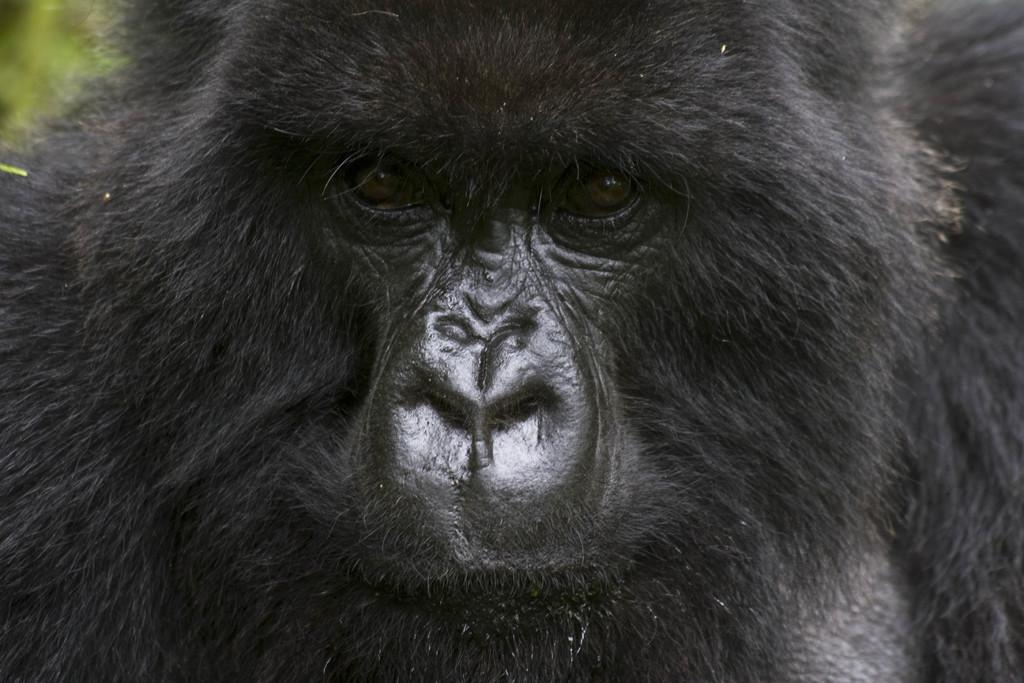What type of animal is in the image? There is a chimpanzee in the image. What type of metal can be seen on the chimpanzee's face in the image? There is no metal present on the chimpanzee's face in the image. 